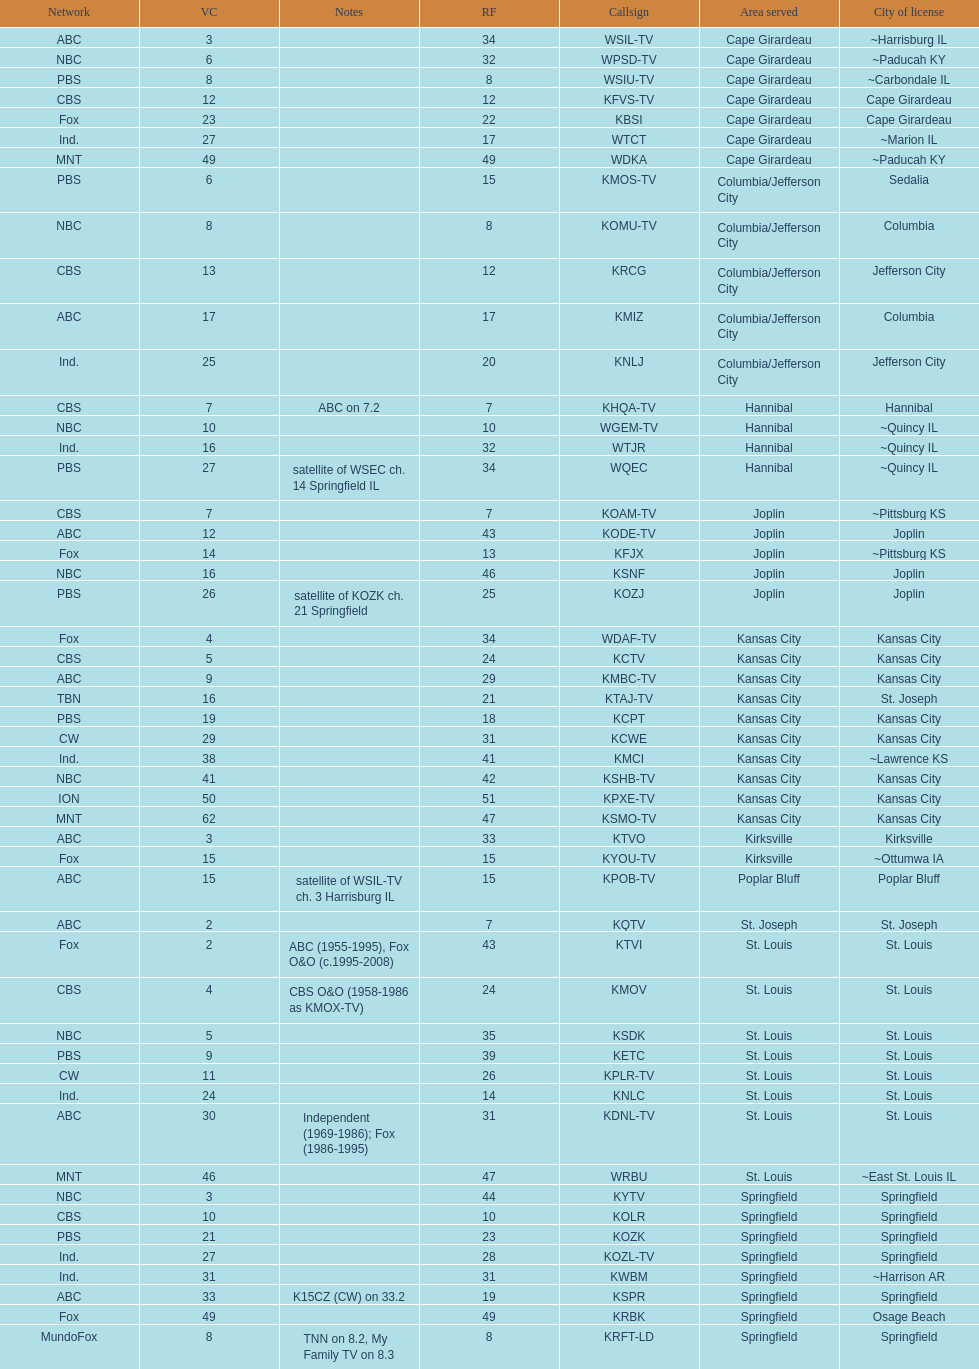Can you give me this table as a dict? {'header': ['Network', 'VC', 'Notes', 'RF', 'Callsign', 'Area served', 'City of license'], 'rows': [['ABC', '3', '', '34', 'WSIL-TV', 'Cape Girardeau', '~Harrisburg IL'], ['NBC', '6', '', '32', 'WPSD-TV', 'Cape Girardeau', '~Paducah KY'], ['PBS', '8', '', '8', 'WSIU-TV', 'Cape Girardeau', '~Carbondale IL'], ['CBS', '12', '', '12', 'KFVS-TV', 'Cape Girardeau', 'Cape Girardeau'], ['Fox', '23', '', '22', 'KBSI', 'Cape Girardeau', 'Cape Girardeau'], ['Ind.', '27', '', '17', 'WTCT', 'Cape Girardeau', '~Marion IL'], ['MNT', '49', '', '49', 'WDKA', 'Cape Girardeau', '~Paducah KY'], ['PBS', '6', '', '15', 'KMOS-TV', 'Columbia/Jefferson City', 'Sedalia'], ['NBC', '8', '', '8', 'KOMU-TV', 'Columbia/Jefferson City', 'Columbia'], ['CBS', '13', '', '12', 'KRCG', 'Columbia/Jefferson City', 'Jefferson City'], ['ABC', '17', '', '17', 'KMIZ', 'Columbia/Jefferson City', 'Columbia'], ['Ind.', '25', '', '20', 'KNLJ', 'Columbia/Jefferson City', 'Jefferson City'], ['CBS', '7', 'ABC on 7.2', '7', 'KHQA-TV', 'Hannibal', 'Hannibal'], ['NBC', '10', '', '10', 'WGEM-TV', 'Hannibal', '~Quincy IL'], ['Ind.', '16', '', '32', 'WTJR', 'Hannibal', '~Quincy IL'], ['PBS', '27', 'satellite of WSEC ch. 14 Springfield IL', '34', 'WQEC', 'Hannibal', '~Quincy IL'], ['CBS', '7', '', '7', 'KOAM-TV', 'Joplin', '~Pittsburg KS'], ['ABC', '12', '', '43', 'KODE-TV', 'Joplin', 'Joplin'], ['Fox', '14', '', '13', 'KFJX', 'Joplin', '~Pittsburg KS'], ['NBC', '16', '', '46', 'KSNF', 'Joplin', 'Joplin'], ['PBS', '26', 'satellite of KOZK ch. 21 Springfield', '25', 'KOZJ', 'Joplin', 'Joplin'], ['Fox', '4', '', '34', 'WDAF-TV', 'Kansas City', 'Kansas City'], ['CBS', '5', '', '24', 'KCTV', 'Kansas City', 'Kansas City'], ['ABC', '9', '', '29', 'KMBC-TV', 'Kansas City', 'Kansas City'], ['TBN', '16', '', '21', 'KTAJ-TV', 'Kansas City', 'St. Joseph'], ['PBS', '19', '', '18', 'KCPT', 'Kansas City', 'Kansas City'], ['CW', '29', '', '31', 'KCWE', 'Kansas City', 'Kansas City'], ['Ind.', '38', '', '41', 'KMCI', 'Kansas City', '~Lawrence KS'], ['NBC', '41', '', '42', 'KSHB-TV', 'Kansas City', 'Kansas City'], ['ION', '50', '', '51', 'KPXE-TV', 'Kansas City', 'Kansas City'], ['MNT', '62', '', '47', 'KSMO-TV', 'Kansas City', 'Kansas City'], ['ABC', '3', '', '33', 'KTVO', 'Kirksville', 'Kirksville'], ['Fox', '15', '', '15', 'KYOU-TV', 'Kirksville', '~Ottumwa IA'], ['ABC', '15', 'satellite of WSIL-TV ch. 3 Harrisburg IL', '15', 'KPOB-TV', 'Poplar Bluff', 'Poplar Bluff'], ['ABC', '2', '', '7', 'KQTV', 'St. Joseph', 'St. Joseph'], ['Fox', '2', 'ABC (1955-1995), Fox O&O (c.1995-2008)', '43', 'KTVI', 'St. Louis', 'St. Louis'], ['CBS', '4', 'CBS O&O (1958-1986 as KMOX-TV)', '24', 'KMOV', 'St. Louis', 'St. Louis'], ['NBC', '5', '', '35', 'KSDK', 'St. Louis', 'St. Louis'], ['PBS', '9', '', '39', 'KETC', 'St. Louis', 'St. Louis'], ['CW', '11', '', '26', 'KPLR-TV', 'St. Louis', 'St. Louis'], ['Ind.', '24', '', '14', 'KNLC', 'St. Louis', 'St. Louis'], ['ABC', '30', 'Independent (1969-1986); Fox (1986-1995)', '31', 'KDNL-TV', 'St. Louis', 'St. Louis'], ['MNT', '46', '', '47', 'WRBU', 'St. Louis', '~East St. Louis IL'], ['NBC', '3', '', '44', 'KYTV', 'Springfield', 'Springfield'], ['CBS', '10', '', '10', 'KOLR', 'Springfield', 'Springfield'], ['PBS', '21', '', '23', 'KOZK', 'Springfield', 'Springfield'], ['Ind.', '27', '', '28', 'KOZL-TV', 'Springfield', 'Springfield'], ['Ind.', '31', '', '31', 'KWBM', 'Springfield', '~Harrison AR'], ['ABC', '33', 'K15CZ (CW) on 33.2', '19', 'KSPR', 'Springfield', 'Springfield'], ['Fox', '49', '', '49', 'KRBK', 'Springfield', 'Osage Beach'], ['MundoFox', '8', 'TNN on 8.2, My Family TV on 8.3', '8', 'KRFT-LD', 'Springfield', 'Springfield']]} Kode-tv and wsil-tv both are a part of which network? ABC. 